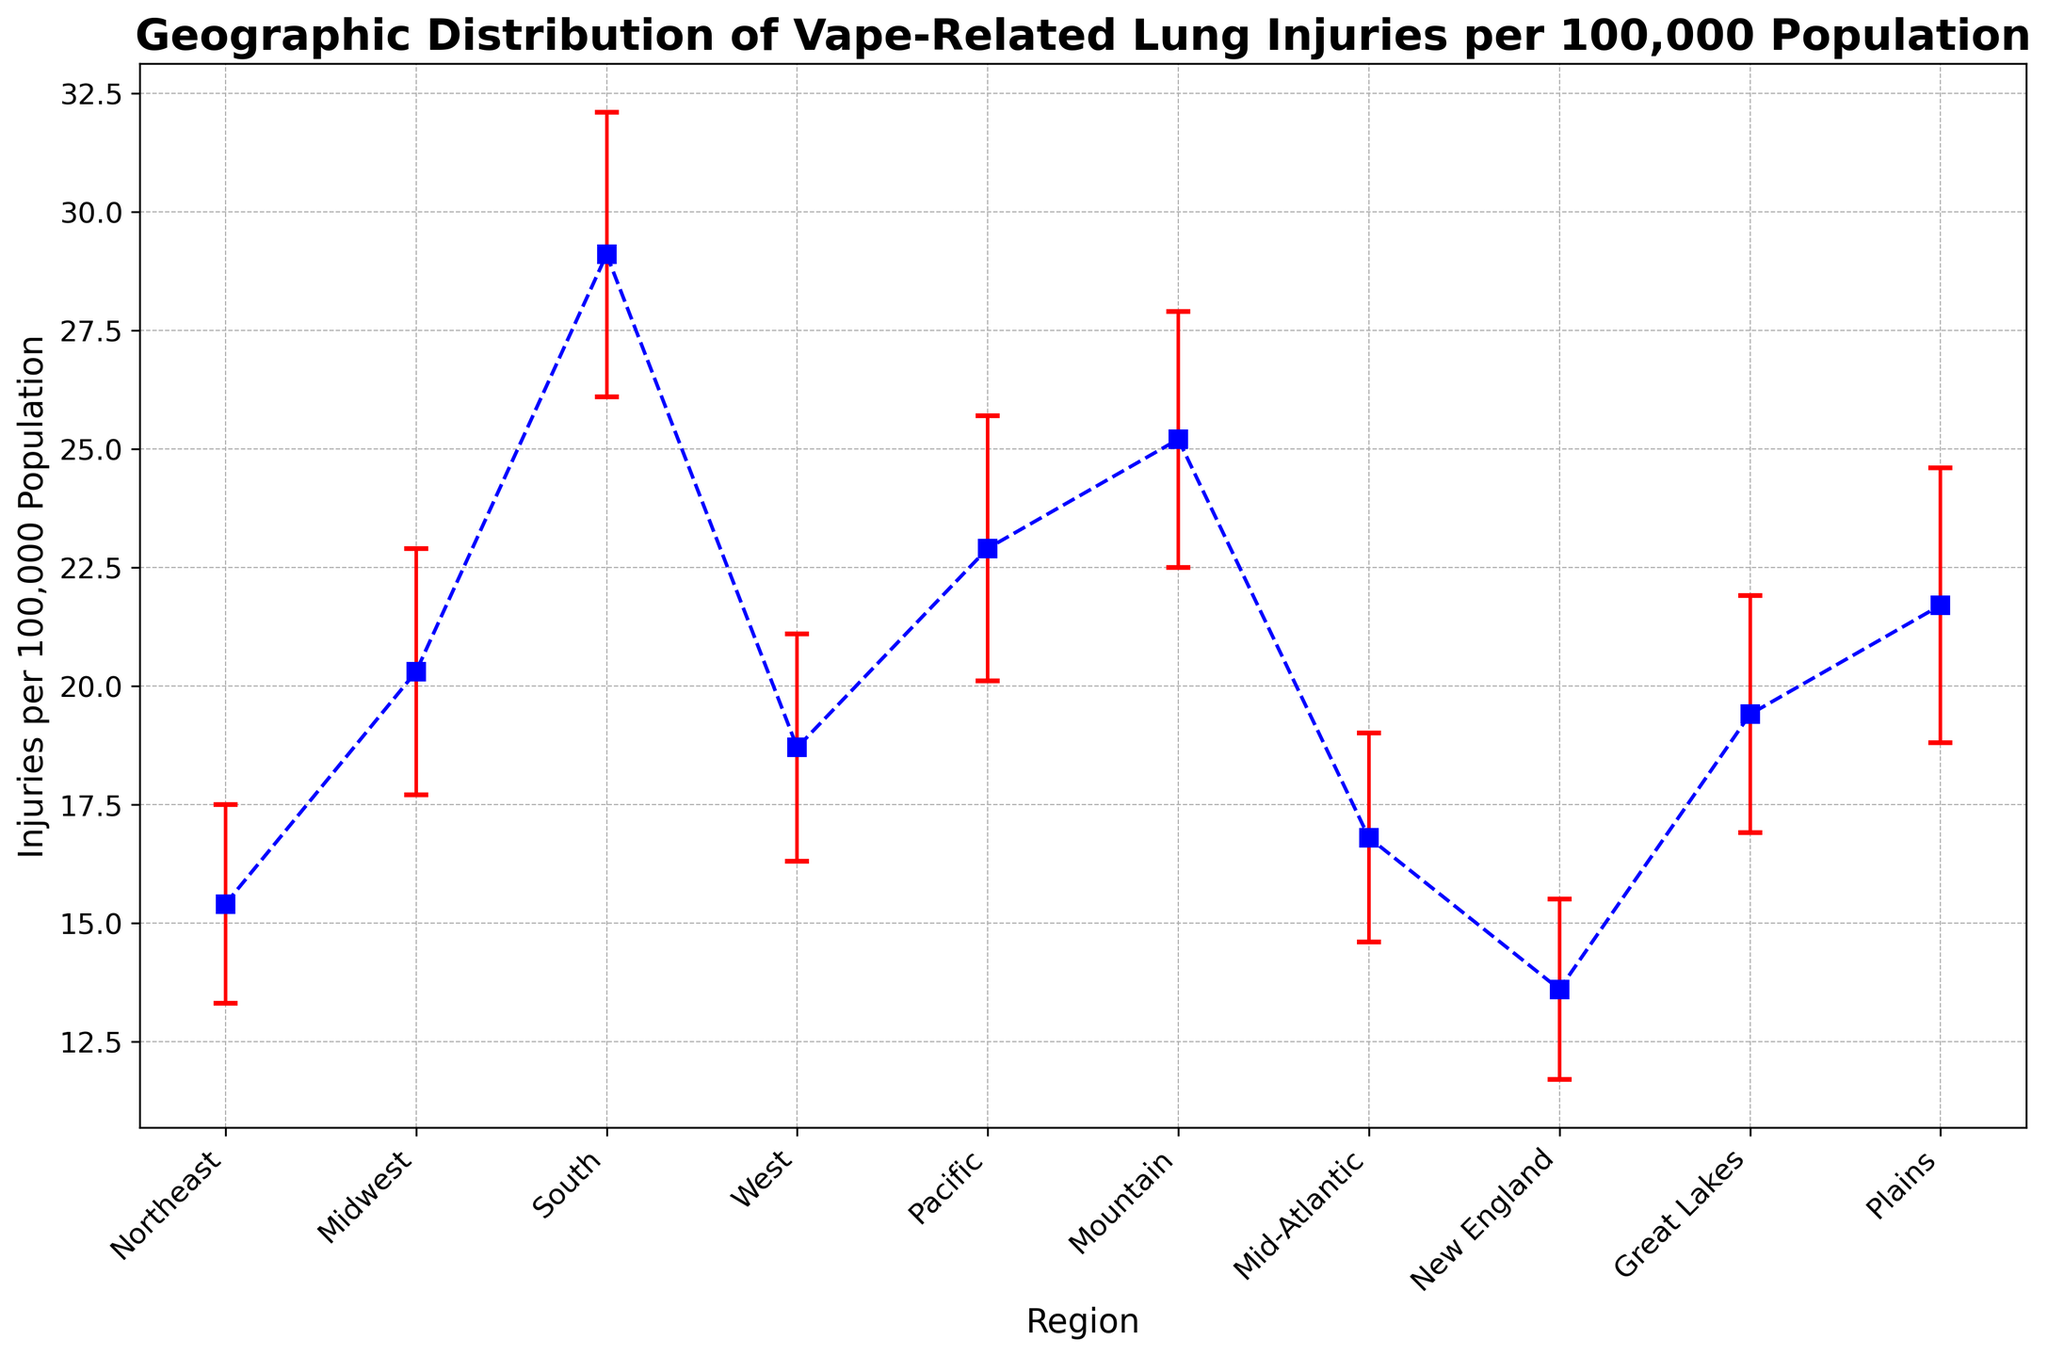How many regions have vape-related lung injuries per 100,000 population greater than 20? Count the regions whose "Injuries_Per_100K" values are greater than 20: Midwest (20.3), South (29.1), Pacific (22.9), Mountain (25.2), Plains (21.7). The result is 5 regions.
Answer: 5 Which region has the lowest rate of vape-related lung injuries per 100,000 population? Look at the "Injuries_Per_100K" values and identify the lowest value, which is 13.6 for New England.
Answer: New England What is the difference in vape-related lung injury rates per 100,000 population between the South and the Northeast? Subtract the "Injuries_Per_100K" value of Northeast (15.4) from that of South (29.1): 29.1 - 15.4 = 13.7.
Answer: 13.7 Which region shows the highest variance in vape-related lung injuries? Compare the "Standard_Deviation" values: the South with a standard deviation of 3.0 has the highest variance.
Answer: South What is the average rate of vape-related lung injuries per 100,000 population across all regions? Sum up the "Injuries_Per_100K" values and divide by the number of regions: (15.4 + 20.3 + 29.1 + 18.7 + 22.9 + 25.2 + 16.8 + 13.6 + 19.4 + 21.7) / 10 ≈ 20.31.
Answer: 20.31 Does the Mid-Atlantic region have a higher rate of vape-related lung injuries compared to the Midwest? Compare the "Injuries_Per_100K" values of Mid-Atlantic (16.8) and Midwest (20.3): 16.8 < 20.3, so Mid-Atlantic has a lower rate.
Answer: No What is the rate range of vape-related lung injuries for the Northeast region considering the error bars? Calculate the range using the "Injuries_Per_100K" and add/subtract the "Standard_Deviation": 15.4 ± 2.1 gives 13.3 to 17.5.
Answer: 13.3 to 17.5 Which regions have an injury rate within one standard deviation of the overall average rate? The overall average rate is 20.31. Calculate the range: 20.31 ± Std Dev. The regions fitting within this range are Northeast, Midwest, West, Mid-Atlantic, New England, and Great Lakes. West (18.7, Std Dev = 2.4), Mid-Atlantic (16.8, Std Dev = 2.2), Northeast (15.4, Std Dev = 2.1).
Answer: Northeast, Midwest, West, Mid-Atlantic, Great Lakes, New England Which regions' error bars overlap? The regions with overlapping error bars are based on their rates and standard deviation values: Northeast (15.4 ± 2.1), Mid-Atlantic (16.8 ± 2.2), West (18.7 ± 2.4), Great Lakes (19.4 ± 2.5), Midwest (20.3 ± 2.6), Plains (21.7 ± 2.9), Pacific (22.9 ± 2.8), and Mountain (25.2 ± 2.7).
Answer: Multiple regions overlap: see overlapping values in the data 